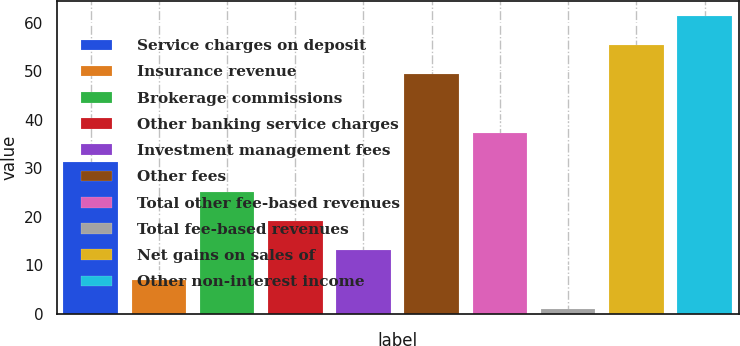<chart> <loc_0><loc_0><loc_500><loc_500><bar_chart><fcel>Service charges on deposit<fcel>Insurance revenue<fcel>Brokerage commissions<fcel>Other banking service charges<fcel>Investment management fees<fcel>Other fees<fcel>Total other fee-based revenues<fcel>Total fee-based revenues<fcel>Net gains on sales of<fcel>Other non-interest income<nl><fcel>31.25<fcel>7.05<fcel>25.2<fcel>19.15<fcel>13.1<fcel>49.4<fcel>37.3<fcel>1<fcel>55.45<fcel>61.5<nl></chart> 